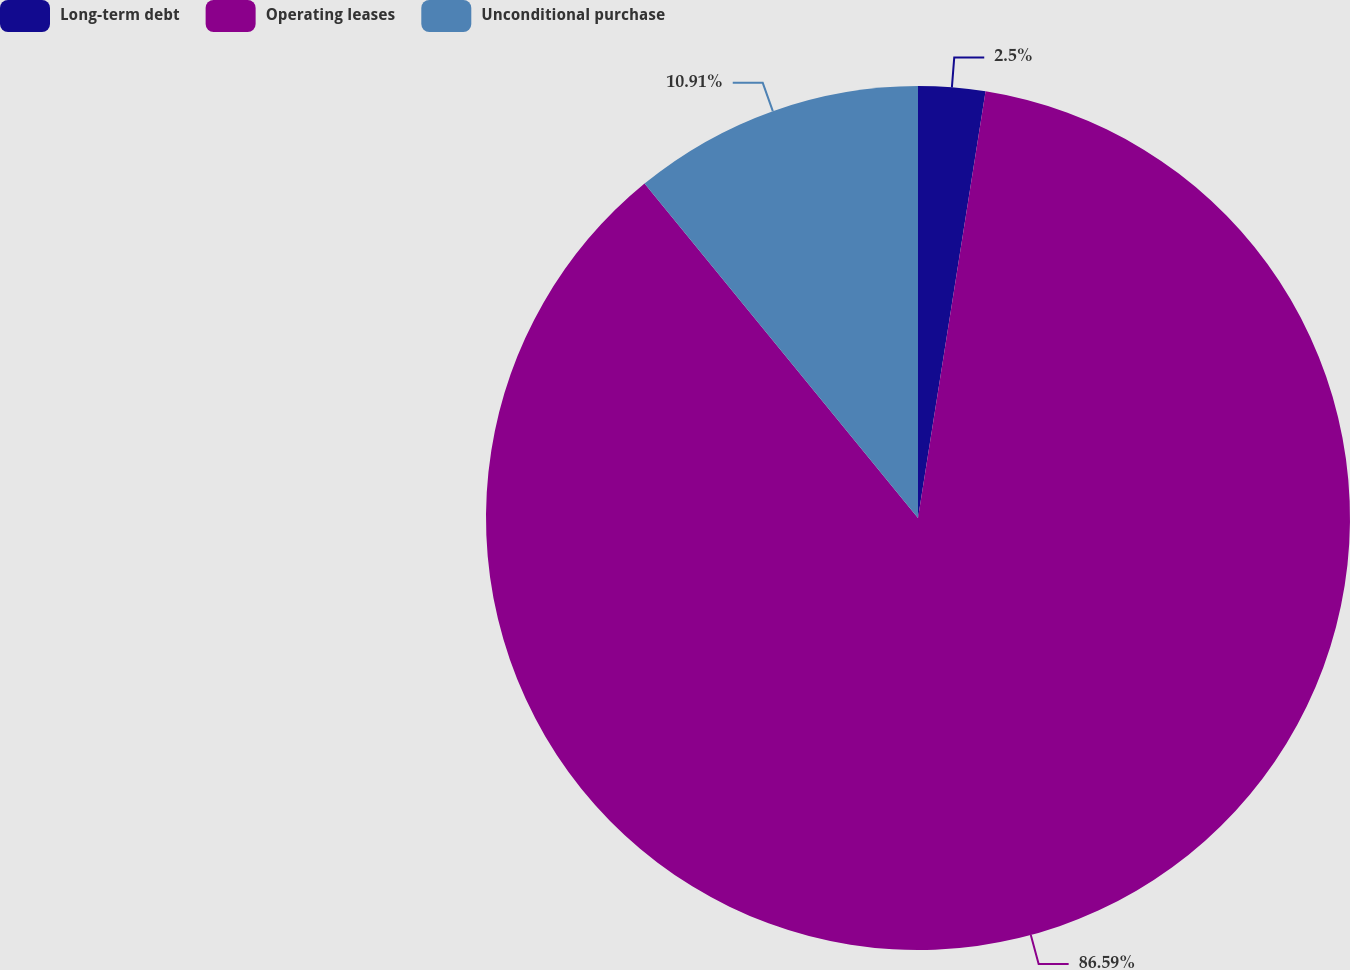Convert chart. <chart><loc_0><loc_0><loc_500><loc_500><pie_chart><fcel>Long-term debt<fcel>Operating leases<fcel>Unconditional purchase<nl><fcel>2.5%<fcel>86.59%<fcel>10.91%<nl></chart> 